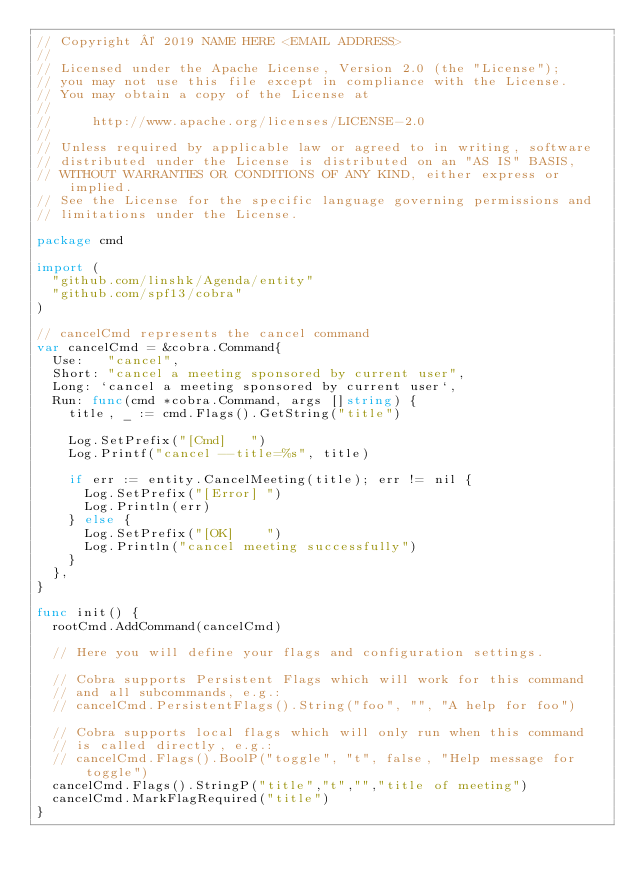Convert code to text. <code><loc_0><loc_0><loc_500><loc_500><_Go_>// Copyright © 2019 NAME HERE <EMAIL ADDRESS>
//
// Licensed under the Apache License, Version 2.0 (the "License");
// you may not use this file except in compliance with the License.
// You may obtain a copy of the License at
//
//     http://www.apache.org/licenses/LICENSE-2.0
//
// Unless required by applicable law or agreed to in writing, software
// distributed under the License is distributed on an "AS IS" BASIS,
// WITHOUT WARRANTIES OR CONDITIONS OF ANY KIND, either express or implied.
// See the License for the specific language governing permissions and
// limitations under the License.

package cmd

import (
	"github.com/linshk/Agenda/entity"
	"github.com/spf13/cobra"
)

// cancelCmd represents the cancel command
var cancelCmd = &cobra.Command{
	Use:   "cancel",
	Short: "cancel a meeting sponsored by current user",
	Long: `cancel a meeting sponsored by current user`,
	Run: func(cmd *cobra.Command, args []string) {
		title, _ := cmd.Flags().GetString("title")

		Log.SetPrefix("[Cmd]   ")
		Log.Printf("cancel --title=%s", title)

		if err := entity.CancelMeeting(title); err != nil {
			Log.SetPrefix("[Error] ")
			Log.Println(err)
		} else {
			Log.SetPrefix("[OK]    ")
			Log.Println("cancel meeting successfully")
		}
	},
}

func init() {
	rootCmd.AddCommand(cancelCmd)

	// Here you will define your flags and configuration settings.

	// Cobra supports Persistent Flags which will work for this command
	// and all subcommands, e.g.:
	// cancelCmd.PersistentFlags().String("foo", "", "A help for foo")

	// Cobra supports local flags which will only run when this command
	// is called directly, e.g.:
	// cancelCmd.Flags().BoolP("toggle", "t", false, "Help message for toggle")
	cancelCmd.Flags().StringP("title","t","","title of meeting")
	cancelCmd.MarkFlagRequired("title")
}
</code> 